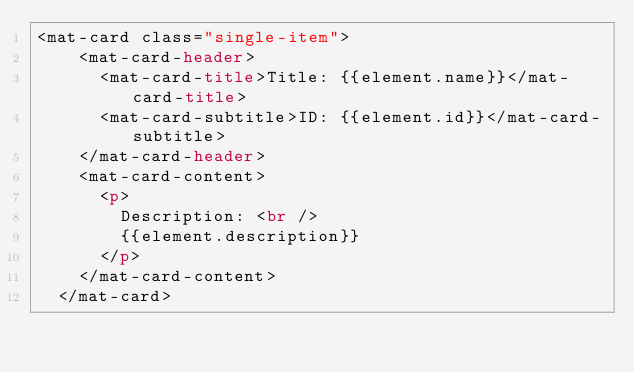<code> <loc_0><loc_0><loc_500><loc_500><_HTML_><mat-card class="single-item">
    <mat-card-header>
      <mat-card-title>Title: {{element.name}}</mat-card-title>
      <mat-card-subtitle>ID: {{element.id}}</mat-card-subtitle>
    </mat-card-header>
    <mat-card-content>
      <p>
        Description: <br />
        {{element.description}}
      </p>
    </mat-card-content>
  </mat-card></code> 